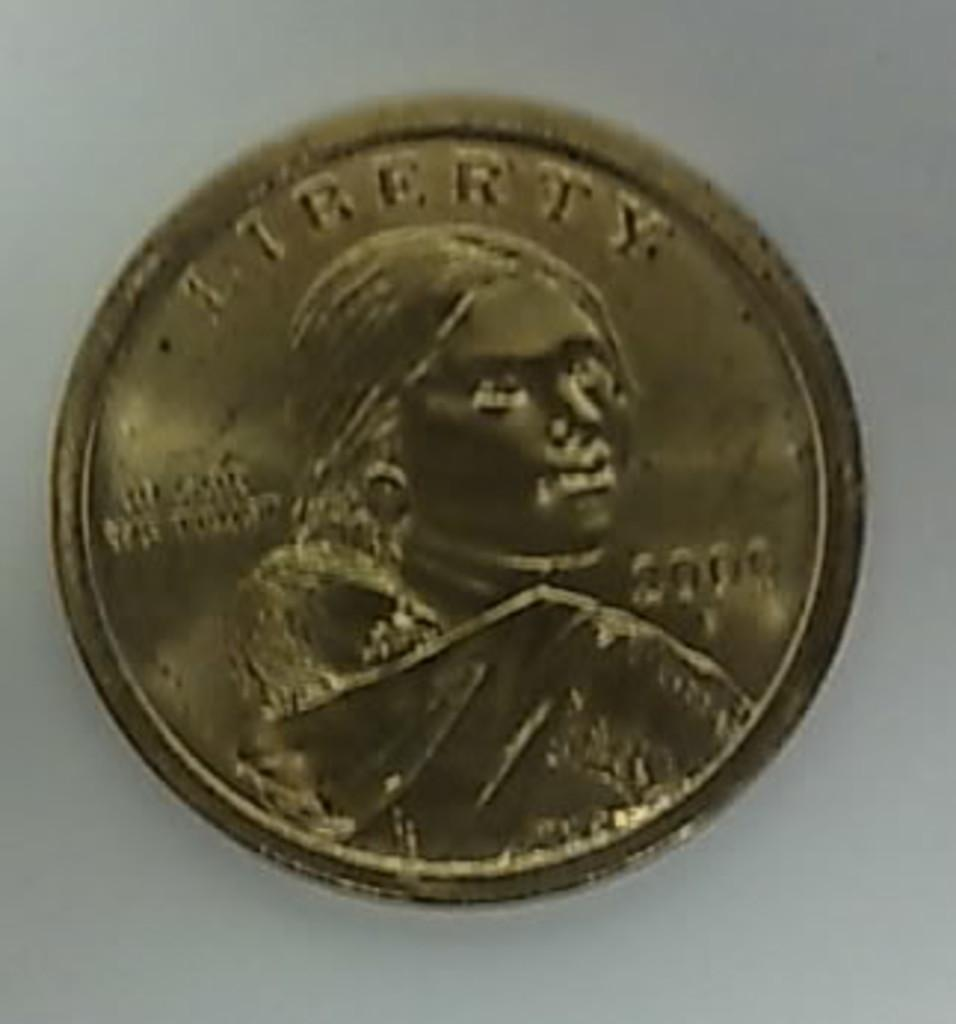Provide a one-sentence caption for the provided image. Copper coin with the word Liberty on the top. 